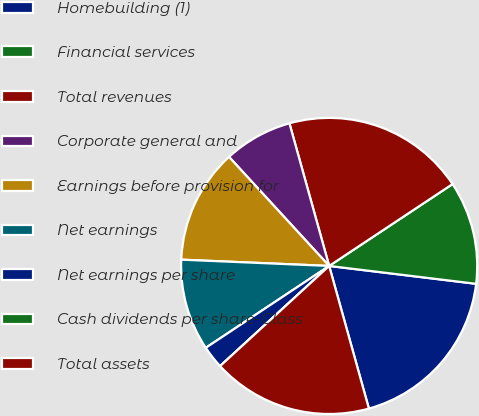<chart> <loc_0><loc_0><loc_500><loc_500><pie_chart><fcel>Homebuilding (1)<fcel>Financial services<fcel>Total revenues<fcel>Corporate general and<fcel>Earnings before provision for<fcel>Net earnings<fcel>Net earnings per share<fcel>Cash dividends per share-Class<fcel>Total assets<nl><fcel>18.75%<fcel>11.25%<fcel>20.0%<fcel>7.5%<fcel>12.5%<fcel>10.0%<fcel>2.5%<fcel>0.0%<fcel>17.5%<nl></chart> 